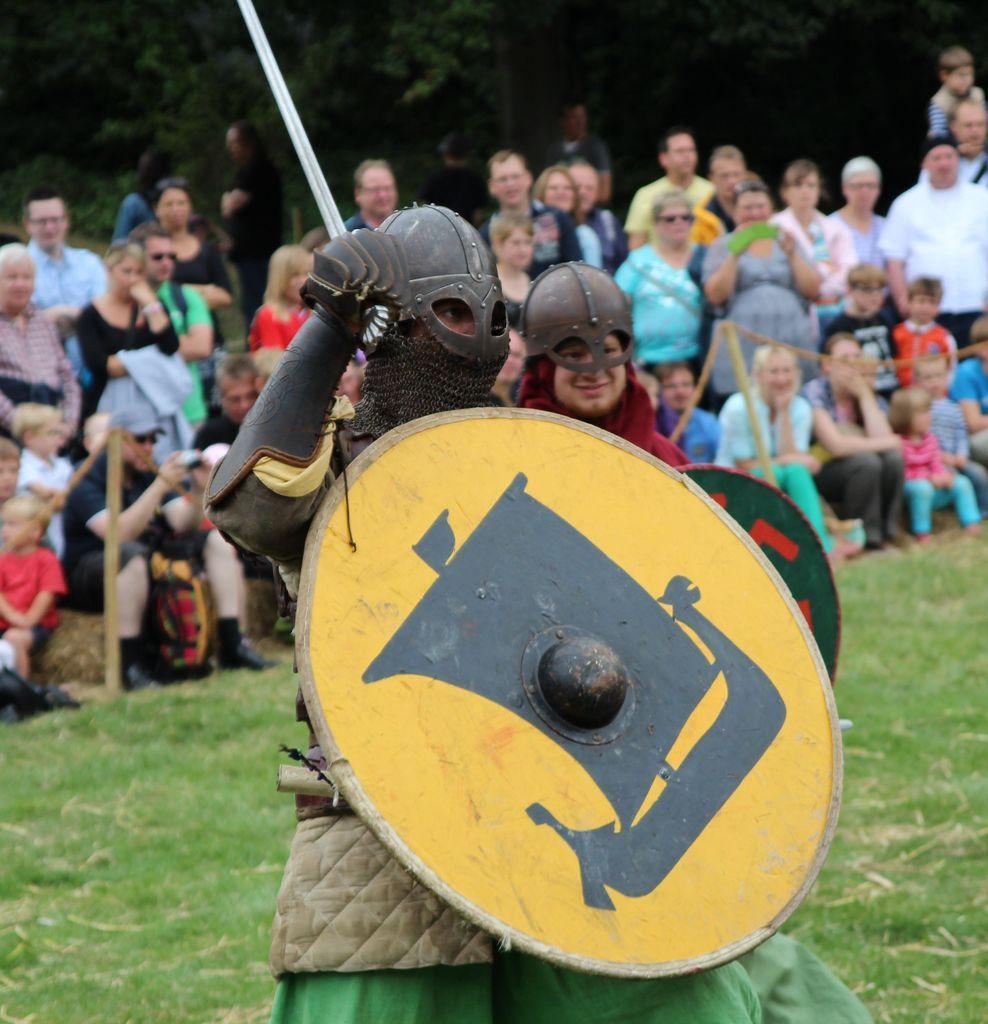Could you give a brief overview of what you see in this image? In the foreground of the image there is a person wearing a helmet and holding a sword and shield. behind him there is another person wearing a helmet and holding a shield. In the background of the image there are people, trees. At the bottom of the image there is grass. 